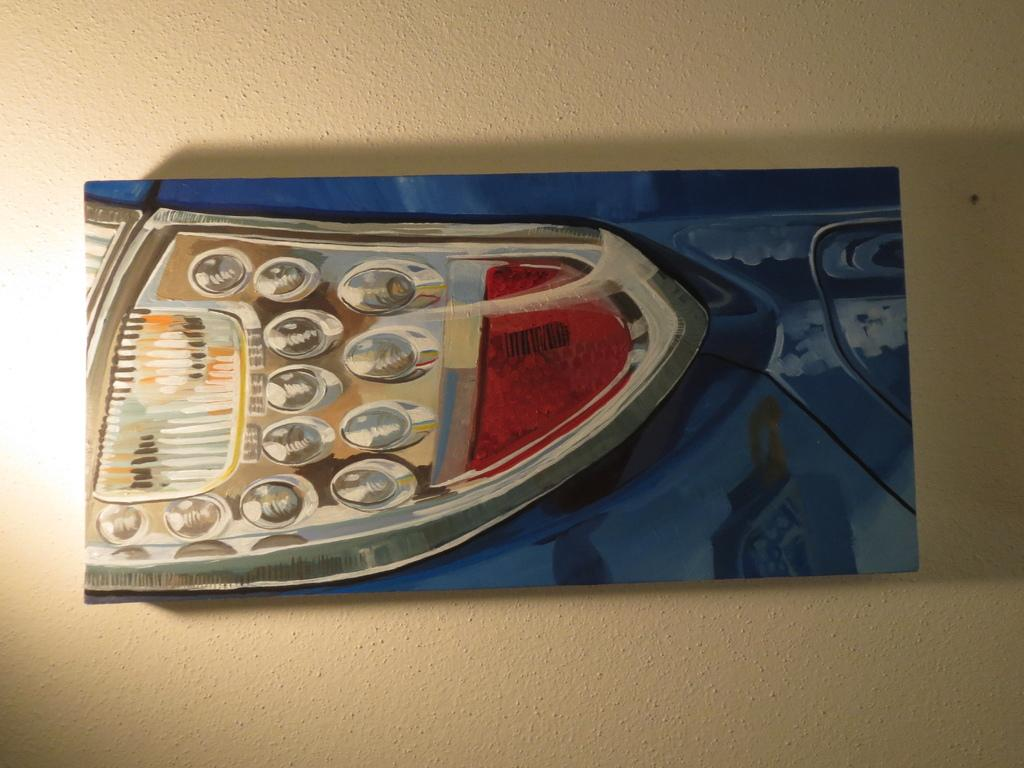What is present on the wall in the image? There is a picture on the wall in the image. What does the picture depict? The picture depicts a blue color car headlight. What type of calendar is hanging on the wall next to the picture? There is no calendar present in the image; only the wall and the picture are visible. 